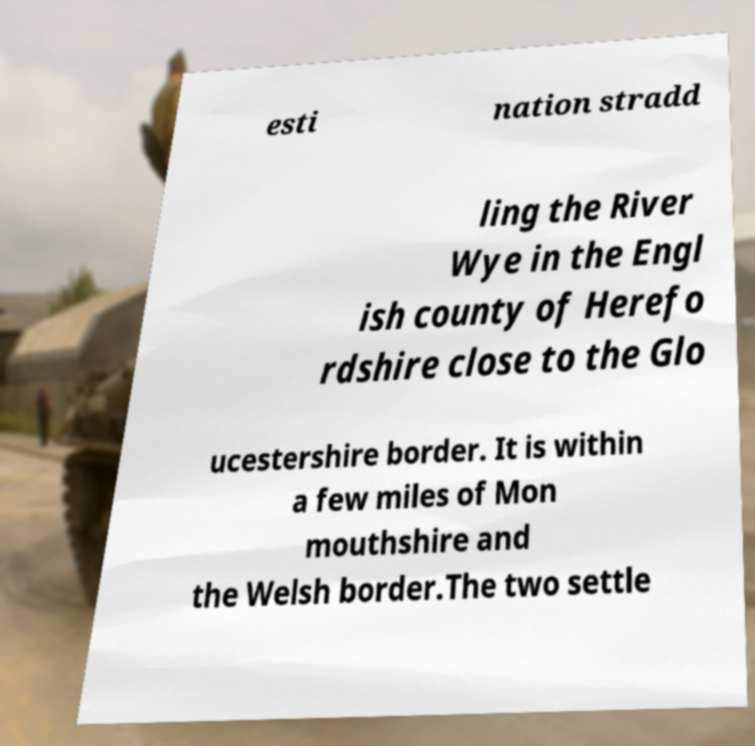What messages or text are displayed in this image? I need them in a readable, typed format. esti nation stradd ling the River Wye in the Engl ish county of Herefo rdshire close to the Glo ucestershire border. It is within a few miles of Mon mouthshire and the Welsh border.The two settle 